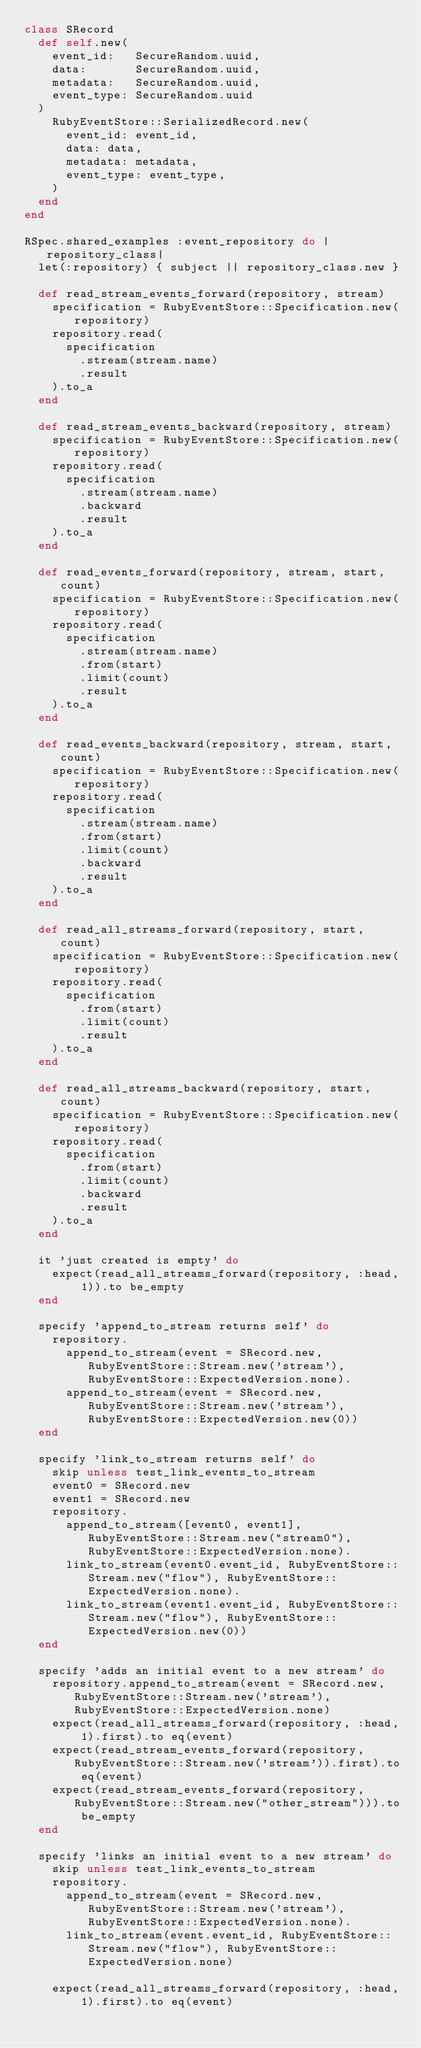Convert code to text. <code><loc_0><loc_0><loc_500><loc_500><_Ruby_>class SRecord
  def self.new(
    event_id:   SecureRandom.uuid,
    data:       SecureRandom.uuid,
    metadata:   SecureRandom.uuid,
    event_type: SecureRandom.uuid
  )
    RubyEventStore::SerializedRecord.new(
      event_id: event_id,
      data: data,
      metadata: metadata,
      event_type: event_type,
    )
  end
end

RSpec.shared_examples :event_repository do |repository_class|
  let(:repository) { subject || repository_class.new }

  def read_stream_events_forward(repository, stream)
    specification = RubyEventStore::Specification.new(repository)
    repository.read(
      specification
        .stream(stream.name)
        .result
    ).to_a
  end

  def read_stream_events_backward(repository, stream)
    specification = RubyEventStore::Specification.new(repository)
    repository.read(
      specification
        .stream(stream.name)
        .backward
        .result
    ).to_a
  end

  def read_events_forward(repository, stream, start, count)
    specification = RubyEventStore::Specification.new(repository)
    repository.read(
      specification
        .stream(stream.name)
        .from(start)
        .limit(count)
        .result
    ).to_a
  end

  def read_events_backward(repository, stream, start, count)
    specification = RubyEventStore::Specification.new(repository)
    repository.read(
      specification
        .stream(stream.name)
        .from(start)
        .limit(count)
        .backward
        .result
    ).to_a
  end

  def read_all_streams_forward(repository, start, count)
    specification = RubyEventStore::Specification.new(repository)
    repository.read(
      specification
        .from(start)
        .limit(count)
        .result
    ).to_a
  end

  def read_all_streams_backward(repository, start, count)
    specification = RubyEventStore::Specification.new(repository)
    repository.read(
      specification
        .from(start)
        .limit(count)
        .backward
        .result
    ).to_a
  end

  it 'just created is empty' do
    expect(read_all_streams_forward(repository, :head, 1)).to be_empty
  end

  specify 'append_to_stream returns self' do
    repository.
      append_to_stream(event = SRecord.new, RubyEventStore::Stream.new('stream'), RubyEventStore::ExpectedVersion.none).
      append_to_stream(event = SRecord.new, RubyEventStore::Stream.new('stream'), RubyEventStore::ExpectedVersion.new(0))
  end

  specify 'link_to_stream returns self' do
    skip unless test_link_events_to_stream
    event0 = SRecord.new
    event1 = SRecord.new
    repository.
      append_to_stream([event0, event1], RubyEventStore::Stream.new("stream0"), RubyEventStore::ExpectedVersion.none).
      link_to_stream(event0.event_id, RubyEventStore::Stream.new("flow"), RubyEventStore::ExpectedVersion.none).
      link_to_stream(event1.event_id, RubyEventStore::Stream.new("flow"), RubyEventStore::ExpectedVersion.new(0))
  end

  specify 'adds an initial event to a new stream' do
    repository.append_to_stream(event = SRecord.new, RubyEventStore::Stream.new('stream'), RubyEventStore::ExpectedVersion.none)
    expect(read_all_streams_forward(repository, :head, 1).first).to eq(event)
    expect(read_stream_events_forward(repository, RubyEventStore::Stream.new('stream')).first).to eq(event)
    expect(read_stream_events_forward(repository, RubyEventStore::Stream.new("other_stream"))).to be_empty
  end

  specify 'links an initial event to a new stream' do
    skip unless test_link_events_to_stream
    repository.
      append_to_stream(event = SRecord.new, RubyEventStore::Stream.new('stream'), RubyEventStore::ExpectedVersion.none).
      link_to_stream(event.event_id, RubyEventStore::Stream.new("flow"), RubyEventStore::ExpectedVersion.none)

    expect(read_all_streams_forward(repository, :head, 1).first).to eq(event)</code> 